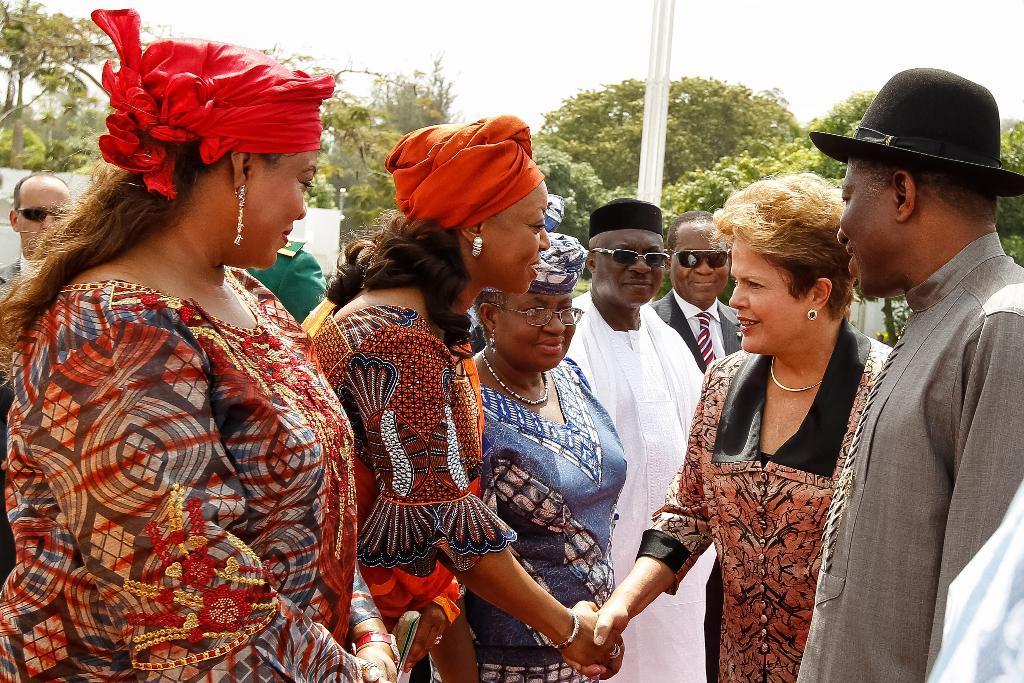Please provide a concise description of this image. In this image we can see persons standing on the ground. In the background we can see trees, pole and sky. 